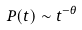Convert formula to latex. <formula><loc_0><loc_0><loc_500><loc_500>P ( t ) \sim t ^ { - \theta }</formula> 